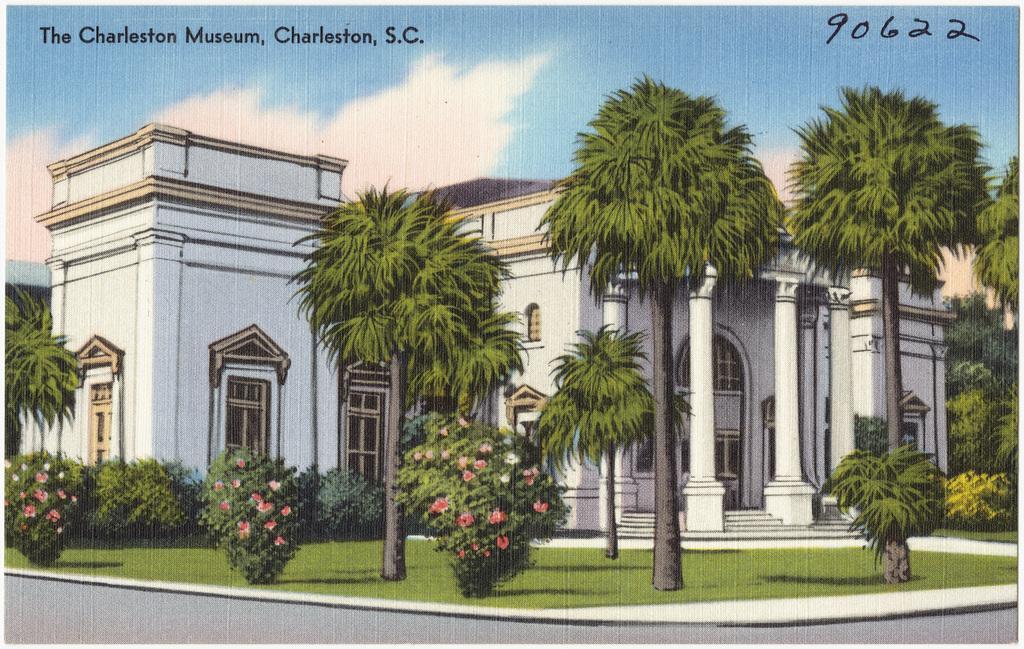How would you summarize this image in a sentence or two? This picture is an edited picture. In this image there is a building and there are trees and there are flowers on the plants. At the top there is sky and there are clouds. At the bottom there is grass and there is a road. At the top left there is a text. 